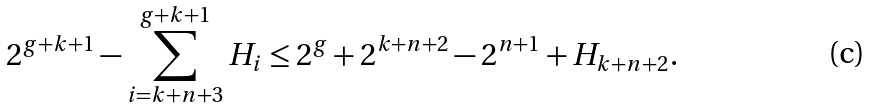Convert formula to latex. <formula><loc_0><loc_0><loc_500><loc_500>2 ^ { g + k + 1 } - \sum _ { i = k + n + 3 } ^ { g + k + 1 } H _ { i } \leq 2 ^ { g } + 2 ^ { k + n + 2 } - 2 ^ { n + 1 } + H _ { k + n + 2 } .</formula> 